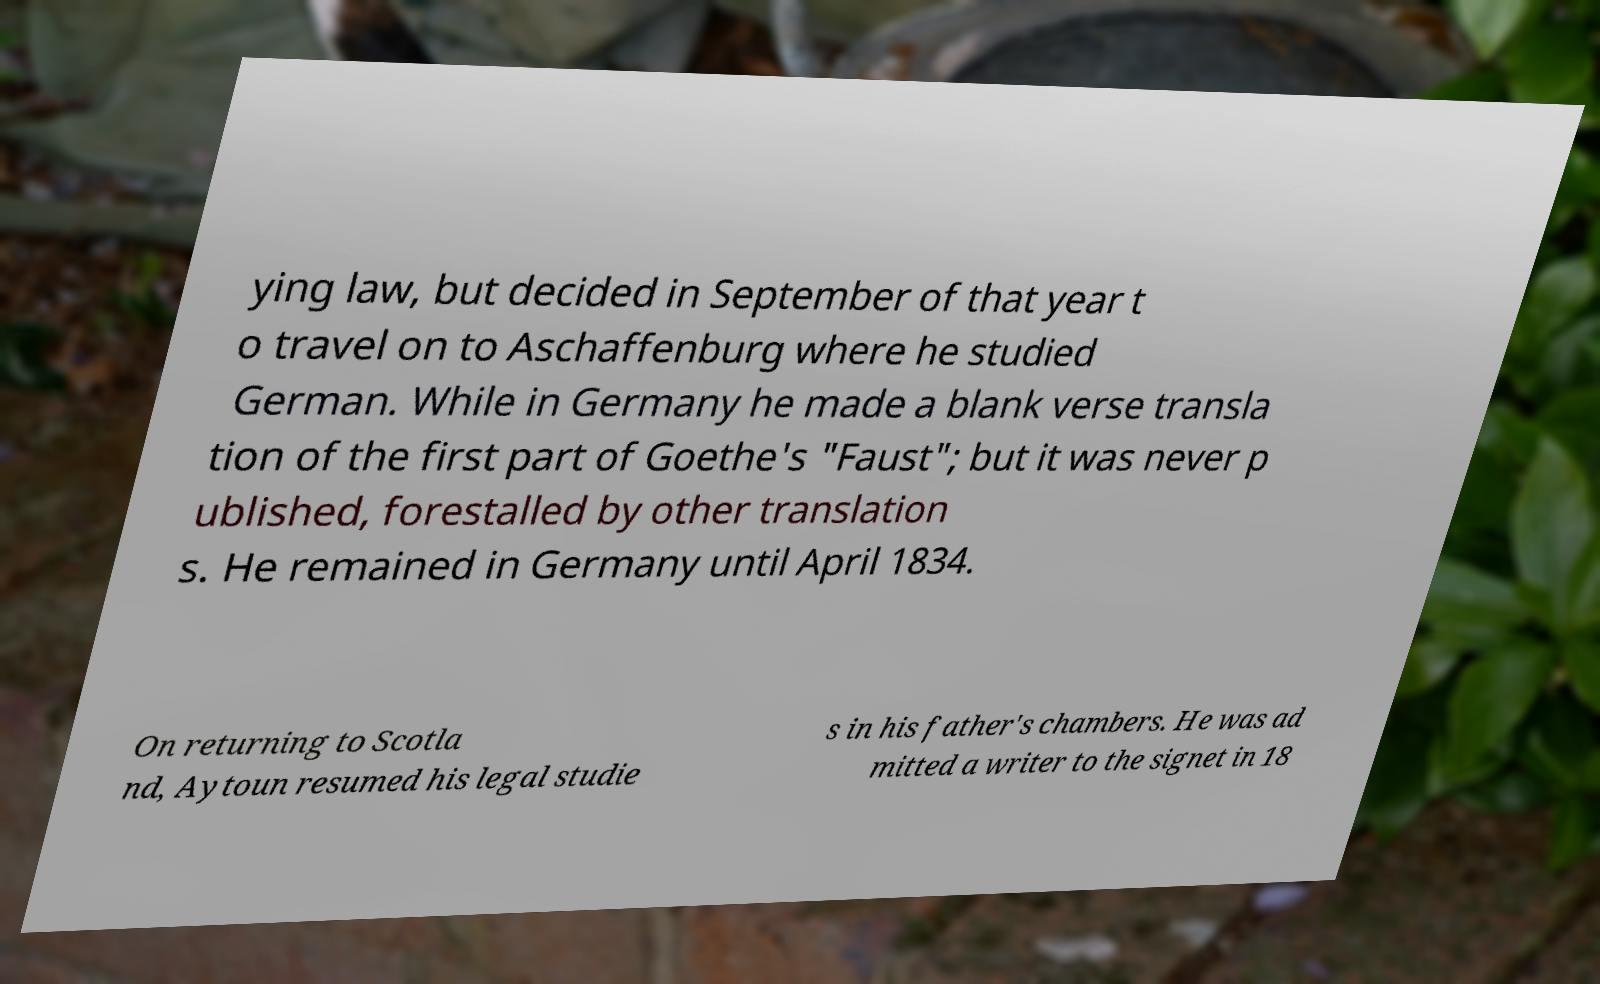Please read and relay the text visible in this image. What does it say? ying law, but decided in September of that year t o travel on to Aschaffenburg where he studied German. While in Germany he made a blank verse transla tion of the first part of Goethe's "Faust"; but it was never p ublished, forestalled by other translation s. He remained in Germany until April 1834. On returning to Scotla nd, Aytoun resumed his legal studie s in his father's chambers. He was ad mitted a writer to the signet in 18 